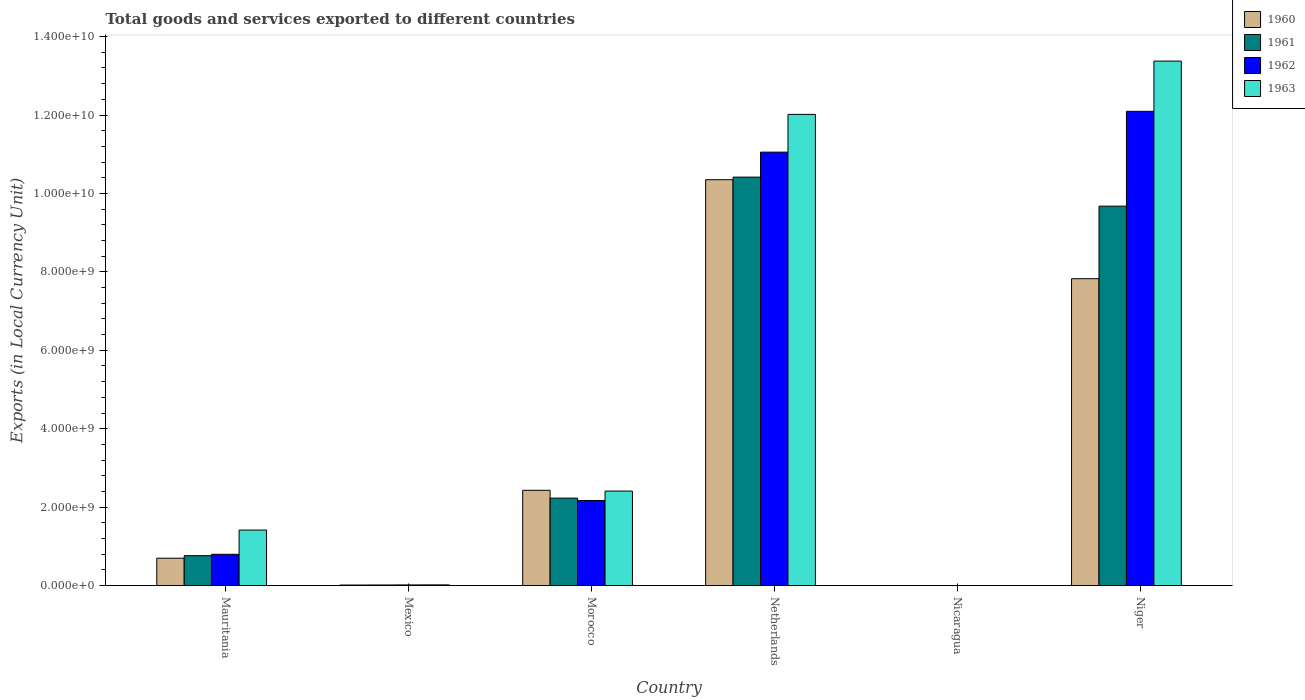How many different coloured bars are there?
Your answer should be very brief. 4. Are the number of bars on each tick of the X-axis equal?
Make the answer very short. Yes. How many bars are there on the 4th tick from the left?
Offer a terse response. 4. How many bars are there on the 6th tick from the right?
Keep it short and to the point. 4. What is the label of the 6th group of bars from the left?
Your answer should be very brief. Niger. In how many cases, is the number of bars for a given country not equal to the number of legend labels?
Make the answer very short. 0. What is the Amount of goods and services exports in 1962 in Netherlands?
Your answer should be very brief. 1.11e+1. Across all countries, what is the maximum Amount of goods and services exports in 1963?
Your answer should be compact. 1.34e+1. Across all countries, what is the minimum Amount of goods and services exports in 1963?
Provide a short and direct response. 0.18. In which country was the Amount of goods and services exports in 1963 maximum?
Offer a very short reply. Niger. In which country was the Amount of goods and services exports in 1961 minimum?
Make the answer very short. Nicaragua. What is the total Amount of goods and services exports in 1962 in the graph?
Your answer should be compact. 2.61e+1. What is the difference between the Amount of goods and services exports in 1962 in Morocco and that in Nicaragua?
Offer a terse response. 2.17e+09. What is the difference between the Amount of goods and services exports in 1962 in Morocco and the Amount of goods and services exports in 1960 in Niger?
Offer a terse response. -5.66e+09. What is the average Amount of goods and services exports in 1960 per country?
Your answer should be compact. 3.55e+09. What is the difference between the Amount of goods and services exports of/in 1962 and Amount of goods and services exports of/in 1963 in Netherlands?
Keep it short and to the point. -9.62e+08. In how many countries, is the Amount of goods and services exports in 1962 greater than 800000000 LCU?
Your response must be concise. 3. What is the ratio of the Amount of goods and services exports in 1963 in Nicaragua to that in Niger?
Ensure brevity in your answer.  1.3255828890398681e-11. Is the Amount of goods and services exports in 1960 in Mauritania less than that in Morocco?
Provide a succinct answer. Yes. Is the difference between the Amount of goods and services exports in 1962 in Mauritania and Niger greater than the difference between the Amount of goods and services exports in 1963 in Mauritania and Niger?
Your answer should be very brief. Yes. What is the difference between the highest and the second highest Amount of goods and services exports in 1961?
Make the answer very short. 8.19e+09. What is the difference between the highest and the lowest Amount of goods and services exports in 1960?
Provide a short and direct response. 1.04e+1. In how many countries, is the Amount of goods and services exports in 1962 greater than the average Amount of goods and services exports in 1962 taken over all countries?
Give a very brief answer. 2. Is the sum of the Amount of goods and services exports in 1960 in Morocco and Nicaragua greater than the maximum Amount of goods and services exports in 1961 across all countries?
Ensure brevity in your answer.  No. Is it the case that in every country, the sum of the Amount of goods and services exports in 1962 and Amount of goods and services exports in 1960 is greater than the sum of Amount of goods and services exports in 1963 and Amount of goods and services exports in 1961?
Make the answer very short. No. How many bars are there?
Provide a short and direct response. 24. Are all the bars in the graph horizontal?
Your answer should be compact. No. What is the difference between two consecutive major ticks on the Y-axis?
Provide a short and direct response. 2.00e+09. Does the graph contain grids?
Give a very brief answer. No. How many legend labels are there?
Offer a very short reply. 4. How are the legend labels stacked?
Make the answer very short. Vertical. What is the title of the graph?
Provide a succinct answer. Total goods and services exported to different countries. Does "2014" appear as one of the legend labels in the graph?
Provide a succinct answer. No. What is the label or title of the Y-axis?
Offer a very short reply. Exports (in Local Currency Unit). What is the Exports (in Local Currency Unit) of 1960 in Mauritania?
Your answer should be very brief. 6.98e+08. What is the Exports (in Local Currency Unit) in 1961 in Mauritania?
Your response must be concise. 7.63e+08. What is the Exports (in Local Currency Unit) of 1962 in Mauritania?
Provide a short and direct response. 7.98e+08. What is the Exports (in Local Currency Unit) of 1963 in Mauritania?
Offer a very short reply. 1.42e+09. What is the Exports (in Local Currency Unit) of 1960 in Mexico?
Offer a very short reply. 1.39e+07. What is the Exports (in Local Currency Unit) of 1961 in Mexico?
Ensure brevity in your answer.  1.49e+07. What is the Exports (in Local Currency Unit) of 1962 in Mexico?
Your response must be concise. 1.63e+07. What is the Exports (in Local Currency Unit) of 1963 in Mexico?
Keep it short and to the point. 1.76e+07. What is the Exports (in Local Currency Unit) in 1960 in Morocco?
Ensure brevity in your answer.  2.43e+09. What is the Exports (in Local Currency Unit) of 1961 in Morocco?
Offer a very short reply. 2.23e+09. What is the Exports (in Local Currency Unit) in 1962 in Morocco?
Your answer should be compact. 2.17e+09. What is the Exports (in Local Currency Unit) of 1963 in Morocco?
Give a very brief answer. 2.41e+09. What is the Exports (in Local Currency Unit) in 1960 in Netherlands?
Provide a succinct answer. 1.04e+1. What is the Exports (in Local Currency Unit) of 1961 in Netherlands?
Make the answer very short. 1.04e+1. What is the Exports (in Local Currency Unit) of 1962 in Netherlands?
Offer a very short reply. 1.11e+1. What is the Exports (in Local Currency Unit) of 1963 in Netherlands?
Ensure brevity in your answer.  1.20e+1. What is the Exports (in Local Currency Unit) of 1960 in Nicaragua?
Make the answer very short. 0.11. What is the Exports (in Local Currency Unit) in 1961 in Nicaragua?
Your answer should be compact. 0.12. What is the Exports (in Local Currency Unit) of 1962 in Nicaragua?
Make the answer very short. 0.15. What is the Exports (in Local Currency Unit) in 1963 in Nicaragua?
Make the answer very short. 0.18. What is the Exports (in Local Currency Unit) of 1960 in Niger?
Your answer should be very brief. 7.83e+09. What is the Exports (in Local Currency Unit) in 1961 in Niger?
Ensure brevity in your answer.  9.68e+09. What is the Exports (in Local Currency Unit) in 1962 in Niger?
Offer a terse response. 1.21e+1. What is the Exports (in Local Currency Unit) of 1963 in Niger?
Offer a very short reply. 1.34e+1. Across all countries, what is the maximum Exports (in Local Currency Unit) in 1960?
Your answer should be very brief. 1.04e+1. Across all countries, what is the maximum Exports (in Local Currency Unit) of 1961?
Give a very brief answer. 1.04e+1. Across all countries, what is the maximum Exports (in Local Currency Unit) of 1962?
Ensure brevity in your answer.  1.21e+1. Across all countries, what is the maximum Exports (in Local Currency Unit) of 1963?
Offer a very short reply. 1.34e+1. Across all countries, what is the minimum Exports (in Local Currency Unit) in 1960?
Provide a succinct answer. 0.11. Across all countries, what is the minimum Exports (in Local Currency Unit) in 1961?
Ensure brevity in your answer.  0.12. Across all countries, what is the minimum Exports (in Local Currency Unit) in 1962?
Ensure brevity in your answer.  0.15. Across all countries, what is the minimum Exports (in Local Currency Unit) of 1963?
Your answer should be very brief. 0.18. What is the total Exports (in Local Currency Unit) in 1960 in the graph?
Provide a succinct answer. 2.13e+1. What is the total Exports (in Local Currency Unit) in 1961 in the graph?
Your answer should be compact. 2.31e+1. What is the total Exports (in Local Currency Unit) in 1962 in the graph?
Offer a terse response. 2.61e+1. What is the total Exports (in Local Currency Unit) of 1963 in the graph?
Provide a succinct answer. 2.92e+1. What is the difference between the Exports (in Local Currency Unit) in 1960 in Mauritania and that in Mexico?
Keep it short and to the point. 6.84e+08. What is the difference between the Exports (in Local Currency Unit) in 1961 in Mauritania and that in Mexico?
Keep it short and to the point. 7.48e+08. What is the difference between the Exports (in Local Currency Unit) in 1962 in Mauritania and that in Mexico?
Give a very brief answer. 7.81e+08. What is the difference between the Exports (in Local Currency Unit) in 1963 in Mauritania and that in Mexico?
Give a very brief answer. 1.40e+09. What is the difference between the Exports (in Local Currency Unit) of 1960 in Mauritania and that in Morocco?
Offer a very short reply. -1.73e+09. What is the difference between the Exports (in Local Currency Unit) of 1961 in Mauritania and that in Morocco?
Make the answer very short. -1.47e+09. What is the difference between the Exports (in Local Currency Unit) of 1962 in Mauritania and that in Morocco?
Your response must be concise. -1.37e+09. What is the difference between the Exports (in Local Currency Unit) in 1963 in Mauritania and that in Morocco?
Make the answer very short. -9.94e+08. What is the difference between the Exports (in Local Currency Unit) in 1960 in Mauritania and that in Netherlands?
Keep it short and to the point. -9.65e+09. What is the difference between the Exports (in Local Currency Unit) of 1961 in Mauritania and that in Netherlands?
Your answer should be very brief. -9.65e+09. What is the difference between the Exports (in Local Currency Unit) of 1962 in Mauritania and that in Netherlands?
Provide a succinct answer. -1.03e+1. What is the difference between the Exports (in Local Currency Unit) of 1963 in Mauritania and that in Netherlands?
Provide a succinct answer. -1.06e+1. What is the difference between the Exports (in Local Currency Unit) of 1960 in Mauritania and that in Nicaragua?
Keep it short and to the point. 6.98e+08. What is the difference between the Exports (in Local Currency Unit) of 1961 in Mauritania and that in Nicaragua?
Ensure brevity in your answer.  7.63e+08. What is the difference between the Exports (in Local Currency Unit) of 1962 in Mauritania and that in Nicaragua?
Make the answer very short. 7.98e+08. What is the difference between the Exports (in Local Currency Unit) of 1963 in Mauritania and that in Nicaragua?
Make the answer very short. 1.42e+09. What is the difference between the Exports (in Local Currency Unit) in 1960 in Mauritania and that in Niger?
Offer a very short reply. -7.13e+09. What is the difference between the Exports (in Local Currency Unit) in 1961 in Mauritania and that in Niger?
Provide a short and direct response. -8.91e+09. What is the difference between the Exports (in Local Currency Unit) of 1962 in Mauritania and that in Niger?
Your response must be concise. -1.13e+1. What is the difference between the Exports (in Local Currency Unit) of 1963 in Mauritania and that in Niger?
Give a very brief answer. -1.20e+1. What is the difference between the Exports (in Local Currency Unit) of 1960 in Mexico and that in Morocco?
Provide a short and direct response. -2.42e+09. What is the difference between the Exports (in Local Currency Unit) in 1961 in Mexico and that in Morocco?
Your answer should be compact. -2.22e+09. What is the difference between the Exports (in Local Currency Unit) in 1962 in Mexico and that in Morocco?
Your answer should be compact. -2.15e+09. What is the difference between the Exports (in Local Currency Unit) in 1963 in Mexico and that in Morocco?
Keep it short and to the point. -2.39e+09. What is the difference between the Exports (in Local Currency Unit) in 1960 in Mexico and that in Netherlands?
Provide a succinct answer. -1.03e+1. What is the difference between the Exports (in Local Currency Unit) in 1961 in Mexico and that in Netherlands?
Offer a terse response. -1.04e+1. What is the difference between the Exports (in Local Currency Unit) in 1962 in Mexico and that in Netherlands?
Your answer should be compact. -1.10e+1. What is the difference between the Exports (in Local Currency Unit) of 1963 in Mexico and that in Netherlands?
Give a very brief answer. -1.20e+1. What is the difference between the Exports (in Local Currency Unit) of 1960 in Mexico and that in Nicaragua?
Give a very brief answer. 1.39e+07. What is the difference between the Exports (in Local Currency Unit) in 1961 in Mexico and that in Nicaragua?
Give a very brief answer. 1.49e+07. What is the difference between the Exports (in Local Currency Unit) of 1962 in Mexico and that in Nicaragua?
Your answer should be very brief. 1.63e+07. What is the difference between the Exports (in Local Currency Unit) in 1963 in Mexico and that in Nicaragua?
Make the answer very short. 1.76e+07. What is the difference between the Exports (in Local Currency Unit) in 1960 in Mexico and that in Niger?
Keep it short and to the point. -7.81e+09. What is the difference between the Exports (in Local Currency Unit) of 1961 in Mexico and that in Niger?
Keep it short and to the point. -9.66e+09. What is the difference between the Exports (in Local Currency Unit) in 1962 in Mexico and that in Niger?
Your answer should be very brief. -1.21e+1. What is the difference between the Exports (in Local Currency Unit) of 1963 in Mexico and that in Niger?
Provide a short and direct response. -1.34e+1. What is the difference between the Exports (in Local Currency Unit) in 1960 in Morocco and that in Netherlands?
Your answer should be very brief. -7.92e+09. What is the difference between the Exports (in Local Currency Unit) of 1961 in Morocco and that in Netherlands?
Make the answer very short. -8.19e+09. What is the difference between the Exports (in Local Currency Unit) of 1962 in Morocco and that in Netherlands?
Your response must be concise. -8.88e+09. What is the difference between the Exports (in Local Currency Unit) of 1963 in Morocco and that in Netherlands?
Ensure brevity in your answer.  -9.61e+09. What is the difference between the Exports (in Local Currency Unit) in 1960 in Morocco and that in Nicaragua?
Ensure brevity in your answer.  2.43e+09. What is the difference between the Exports (in Local Currency Unit) of 1961 in Morocco and that in Nicaragua?
Ensure brevity in your answer.  2.23e+09. What is the difference between the Exports (in Local Currency Unit) of 1962 in Morocco and that in Nicaragua?
Your answer should be very brief. 2.17e+09. What is the difference between the Exports (in Local Currency Unit) of 1963 in Morocco and that in Nicaragua?
Your answer should be very brief. 2.41e+09. What is the difference between the Exports (in Local Currency Unit) in 1960 in Morocco and that in Niger?
Keep it short and to the point. -5.40e+09. What is the difference between the Exports (in Local Currency Unit) of 1961 in Morocco and that in Niger?
Your response must be concise. -7.45e+09. What is the difference between the Exports (in Local Currency Unit) in 1962 in Morocco and that in Niger?
Make the answer very short. -9.92e+09. What is the difference between the Exports (in Local Currency Unit) of 1963 in Morocco and that in Niger?
Your answer should be very brief. -1.10e+1. What is the difference between the Exports (in Local Currency Unit) in 1960 in Netherlands and that in Nicaragua?
Your answer should be compact. 1.04e+1. What is the difference between the Exports (in Local Currency Unit) of 1961 in Netherlands and that in Nicaragua?
Offer a terse response. 1.04e+1. What is the difference between the Exports (in Local Currency Unit) in 1962 in Netherlands and that in Nicaragua?
Offer a terse response. 1.11e+1. What is the difference between the Exports (in Local Currency Unit) of 1963 in Netherlands and that in Nicaragua?
Your response must be concise. 1.20e+1. What is the difference between the Exports (in Local Currency Unit) in 1960 in Netherlands and that in Niger?
Your answer should be very brief. 2.52e+09. What is the difference between the Exports (in Local Currency Unit) of 1961 in Netherlands and that in Niger?
Your response must be concise. 7.41e+08. What is the difference between the Exports (in Local Currency Unit) of 1962 in Netherlands and that in Niger?
Your answer should be compact. -1.04e+09. What is the difference between the Exports (in Local Currency Unit) of 1963 in Netherlands and that in Niger?
Make the answer very short. -1.36e+09. What is the difference between the Exports (in Local Currency Unit) of 1960 in Nicaragua and that in Niger?
Ensure brevity in your answer.  -7.83e+09. What is the difference between the Exports (in Local Currency Unit) of 1961 in Nicaragua and that in Niger?
Offer a terse response. -9.68e+09. What is the difference between the Exports (in Local Currency Unit) of 1962 in Nicaragua and that in Niger?
Make the answer very short. -1.21e+1. What is the difference between the Exports (in Local Currency Unit) of 1963 in Nicaragua and that in Niger?
Provide a short and direct response. -1.34e+1. What is the difference between the Exports (in Local Currency Unit) in 1960 in Mauritania and the Exports (in Local Currency Unit) in 1961 in Mexico?
Offer a very short reply. 6.83e+08. What is the difference between the Exports (in Local Currency Unit) in 1960 in Mauritania and the Exports (in Local Currency Unit) in 1962 in Mexico?
Provide a short and direct response. 6.82e+08. What is the difference between the Exports (in Local Currency Unit) of 1960 in Mauritania and the Exports (in Local Currency Unit) of 1963 in Mexico?
Keep it short and to the point. 6.80e+08. What is the difference between the Exports (in Local Currency Unit) of 1961 in Mauritania and the Exports (in Local Currency Unit) of 1962 in Mexico?
Offer a terse response. 7.46e+08. What is the difference between the Exports (in Local Currency Unit) of 1961 in Mauritania and the Exports (in Local Currency Unit) of 1963 in Mexico?
Provide a succinct answer. 7.45e+08. What is the difference between the Exports (in Local Currency Unit) in 1962 in Mauritania and the Exports (in Local Currency Unit) in 1963 in Mexico?
Your answer should be very brief. 7.80e+08. What is the difference between the Exports (in Local Currency Unit) of 1960 in Mauritania and the Exports (in Local Currency Unit) of 1961 in Morocco?
Keep it short and to the point. -1.53e+09. What is the difference between the Exports (in Local Currency Unit) in 1960 in Mauritania and the Exports (in Local Currency Unit) in 1962 in Morocco?
Offer a very short reply. -1.47e+09. What is the difference between the Exports (in Local Currency Unit) in 1960 in Mauritania and the Exports (in Local Currency Unit) in 1963 in Morocco?
Offer a very short reply. -1.71e+09. What is the difference between the Exports (in Local Currency Unit) in 1961 in Mauritania and the Exports (in Local Currency Unit) in 1962 in Morocco?
Keep it short and to the point. -1.41e+09. What is the difference between the Exports (in Local Currency Unit) of 1961 in Mauritania and the Exports (in Local Currency Unit) of 1963 in Morocco?
Offer a terse response. -1.65e+09. What is the difference between the Exports (in Local Currency Unit) in 1962 in Mauritania and the Exports (in Local Currency Unit) in 1963 in Morocco?
Give a very brief answer. -1.61e+09. What is the difference between the Exports (in Local Currency Unit) of 1960 in Mauritania and the Exports (in Local Currency Unit) of 1961 in Netherlands?
Keep it short and to the point. -9.72e+09. What is the difference between the Exports (in Local Currency Unit) in 1960 in Mauritania and the Exports (in Local Currency Unit) in 1962 in Netherlands?
Offer a very short reply. -1.04e+1. What is the difference between the Exports (in Local Currency Unit) in 1960 in Mauritania and the Exports (in Local Currency Unit) in 1963 in Netherlands?
Offer a very short reply. -1.13e+1. What is the difference between the Exports (in Local Currency Unit) in 1961 in Mauritania and the Exports (in Local Currency Unit) in 1962 in Netherlands?
Give a very brief answer. -1.03e+1. What is the difference between the Exports (in Local Currency Unit) in 1961 in Mauritania and the Exports (in Local Currency Unit) in 1963 in Netherlands?
Your response must be concise. -1.13e+1. What is the difference between the Exports (in Local Currency Unit) of 1962 in Mauritania and the Exports (in Local Currency Unit) of 1963 in Netherlands?
Your answer should be compact. -1.12e+1. What is the difference between the Exports (in Local Currency Unit) in 1960 in Mauritania and the Exports (in Local Currency Unit) in 1961 in Nicaragua?
Provide a succinct answer. 6.98e+08. What is the difference between the Exports (in Local Currency Unit) of 1960 in Mauritania and the Exports (in Local Currency Unit) of 1962 in Nicaragua?
Ensure brevity in your answer.  6.98e+08. What is the difference between the Exports (in Local Currency Unit) in 1960 in Mauritania and the Exports (in Local Currency Unit) in 1963 in Nicaragua?
Keep it short and to the point. 6.98e+08. What is the difference between the Exports (in Local Currency Unit) of 1961 in Mauritania and the Exports (in Local Currency Unit) of 1962 in Nicaragua?
Make the answer very short. 7.63e+08. What is the difference between the Exports (in Local Currency Unit) in 1961 in Mauritania and the Exports (in Local Currency Unit) in 1963 in Nicaragua?
Make the answer very short. 7.63e+08. What is the difference between the Exports (in Local Currency Unit) in 1962 in Mauritania and the Exports (in Local Currency Unit) in 1963 in Nicaragua?
Make the answer very short. 7.98e+08. What is the difference between the Exports (in Local Currency Unit) of 1960 in Mauritania and the Exports (in Local Currency Unit) of 1961 in Niger?
Your response must be concise. -8.98e+09. What is the difference between the Exports (in Local Currency Unit) of 1960 in Mauritania and the Exports (in Local Currency Unit) of 1962 in Niger?
Provide a short and direct response. -1.14e+1. What is the difference between the Exports (in Local Currency Unit) in 1960 in Mauritania and the Exports (in Local Currency Unit) in 1963 in Niger?
Offer a very short reply. -1.27e+1. What is the difference between the Exports (in Local Currency Unit) of 1961 in Mauritania and the Exports (in Local Currency Unit) of 1962 in Niger?
Your answer should be compact. -1.13e+1. What is the difference between the Exports (in Local Currency Unit) of 1961 in Mauritania and the Exports (in Local Currency Unit) of 1963 in Niger?
Ensure brevity in your answer.  -1.26e+1. What is the difference between the Exports (in Local Currency Unit) of 1962 in Mauritania and the Exports (in Local Currency Unit) of 1963 in Niger?
Offer a terse response. -1.26e+1. What is the difference between the Exports (in Local Currency Unit) of 1960 in Mexico and the Exports (in Local Currency Unit) of 1961 in Morocco?
Your answer should be compact. -2.22e+09. What is the difference between the Exports (in Local Currency Unit) in 1960 in Mexico and the Exports (in Local Currency Unit) in 1962 in Morocco?
Your answer should be very brief. -2.16e+09. What is the difference between the Exports (in Local Currency Unit) in 1960 in Mexico and the Exports (in Local Currency Unit) in 1963 in Morocco?
Offer a very short reply. -2.40e+09. What is the difference between the Exports (in Local Currency Unit) of 1961 in Mexico and the Exports (in Local Currency Unit) of 1962 in Morocco?
Provide a succinct answer. -2.16e+09. What is the difference between the Exports (in Local Currency Unit) in 1961 in Mexico and the Exports (in Local Currency Unit) in 1963 in Morocco?
Your answer should be very brief. -2.40e+09. What is the difference between the Exports (in Local Currency Unit) of 1962 in Mexico and the Exports (in Local Currency Unit) of 1963 in Morocco?
Make the answer very short. -2.39e+09. What is the difference between the Exports (in Local Currency Unit) in 1960 in Mexico and the Exports (in Local Currency Unit) in 1961 in Netherlands?
Make the answer very short. -1.04e+1. What is the difference between the Exports (in Local Currency Unit) of 1960 in Mexico and the Exports (in Local Currency Unit) of 1962 in Netherlands?
Your answer should be compact. -1.10e+1. What is the difference between the Exports (in Local Currency Unit) in 1960 in Mexico and the Exports (in Local Currency Unit) in 1963 in Netherlands?
Provide a short and direct response. -1.20e+1. What is the difference between the Exports (in Local Currency Unit) of 1961 in Mexico and the Exports (in Local Currency Unit) of 1962 in Netherlands?
Your answer should be compact. -1.10e+1. What is the difference between the Exports (in Local Currency Unit) in 1961 in Mexico and the Exports (in Local Currency Unit) in 1963 in Netherlands?
Ensure brevity in your answer.  -1.20e+1. What is the difference between the Exports (in Local Currency Unit) of 1962 in Mexico and the Exports (in Local Currency Unit) of 1963 in Netherlands?
Keep it short and to the point. -1.20e+1. What is the difference between the Exports (in Local Currency Unit) of 1960 in Mexico and the Exports (in Local Currency Unit) of 1961 in Nicaragua?
Ensure brevity in your answer.  1.39e+07. What is the difference between the Exports (in Local Currency Unit) of 1960 in Mexico and the Exports (in Local Currency Unit) of 1962 in Nicaragua?
Make the answer very short. 1.39e+07. What is the difference between the Exports (in Local Currency Unit) in 1960 in Mexico and the Exports (in Local Currency Unit) in 1963 in Nicaragua?
Offer a very short reply. 1.39e+07. What is the difference between the Exports (in Local Currency Unit) of 1961 in Mexico and the Exports (in Local Currency Unit) of 1962 in Nicaragua?
Offer a terse response. 1.49e+07. What is the difference between the Exports (in Local Currency Unit) in 1961 in Mexico and the Exports (in Local Currency Unit) in 1963 in Nicaragua?
Provide a succinct answer. 1.49e+07. What is the difference between the Exports (in Local Currency Unit) in 1962 in Mexico and the Exports (in Local Currency Unit) in 1963 in Nicaragua?
Keep it short and to the point. 1.63e+07. What is the difference between the Exports (in Local Currency Unit) of 1960 in Mexico and the Exports (in Local Currency Unit) of 1961 in Niger?
Your answer should be compact. -9.66e+09. What is the difference between the Exports (in Local Currency Unit) in 1960 in Mexico and the Exports (in Local Currency Unit) in 1962 in Niger?
Your response must be concise. -1.21e+1. What is the difference between the Exports (in Local Currency Unit) in 1960 in Mexico and the Exports (in Local Currency Unit) in 1963 in Niger?
Keep it short and to the point. -1.34e+1. What is the difference between the Exports (in Local Currency Unit) in 1961 in Mexico and the Exports (in Local Currency Unit) in 1962 in Niger?
Offer a very short reply. -1.21e+1. What is the difference between the Exports (in Local Currency Unit) of 1961 in Mexico and the Exports (in Local Currency Unit) of 1963 in Niger?
Provide a short and direct response. -1.34e+1. What is the difference between the Exports (in Local Currency Unit) of 1962 in Mexico and the Exports (in Local Currency Unit) of 1963 in Niger?
Offer a very short reply. -1.34e+1. What is the difference between the Exports (in Local Currency Unit) of 1960 in Morocco and the Exports (in Local Currency Unit) of 1961 in Netherlands?
Give a very brief answer. -7.99e+09. What is the difference between the Exports (in Local Currency Unit) in 1960 in Morocco and the Exports (in Local Currency Unit) in 1962 in Netherlands?
Ensure brevity in your answer.  -8.62e+09. What is the difference between the Exports (in Local Currency Unit) of 1960 in Morocco and the Exports (in Local Currency Unit) of 1963 in Netherlands?
Make the answer very short. -9.59e+09. What is the difference between the Exports (in Local Currency Unit) of 1961 in Morocco and the Exports (in Local Currency Unit) of 1962 in Netherlands?
Keep it short and to the point. -8.82e+09. What is the difference between the Exports (in Local Currency Unit) of 1961 in Morocco and the Exports (in Local Currency Unit) of 1963 in Netherlands?
Keep it short and to the point. -9.79e+09. What is the difference between the Exports (in Local Currency Unit) in 1962 in Morocco and the Exports (in Local Currency Unit) in 1963 in Netherlands?
Make the answer very short. -9.85e+09. What is the difference between the Exports (in Local Currency Unit) in 1960 in Morocco and the Exports (in Local Currency Unit) in 1961 in Nicaragua?
Give a very brief answer. 2.43e+09. What is the difference between the Exports (in Local Currency Unit) in 1960 in Morocco and the Exports (in Local Currency Unit) in 1962 in Nicaragua?
Give a very brief answer. 2.43e+09. What is the difference between the Exports (in Local Currency Unit) of 1960 in Morocco and the Exports (in Local Currency Unit) of 1963 in Nicaragua?
Make the answer very short. 2.43e+09. What is the difference between the Exports (in Local Currency Unit) of 1961 in Morocco and the Exports (in Local Currency Unit) of 1962 in Nicaragua?
Offer a very short reply. 2.23e+09. What is the difference between the Exports (in Local Currency Unit) of 1961 in Morocco and the Exports (in Local Currency Unit) of 1963 in Nicaragua?
Offer a very short reply. 2.23e+09. What is the difference between the Exports (in Local Currency Unit) in 1962 in Morocco and the Exports (in Local Currency Unit) in 1963 in Nicaragua?
Provide a short and direct response. 2.17e+09. What is the difference between the Exports (in Local Currency Unit) of 1960 in Morocco and the Exports (in Local Currency Unit) of 1961 in Niger?
Your answer should be compact. -7.25e+09. What is the difference between the Exports (in Local Currency Unit) in 1960 in Morocco and the Exports (in Local Currency Unit) in 1962 in Niger?
Ensure brevity in your answer.  -9.66e+09. What is the difference between the Exports (in Local Currency Unit) in 1960 in Morocco and the Exports (in Local Currency Unit) in 1963 in Niger?
Your response must be concise. -1.09e+1. What is the difference between the Exports (in Local Currency Unit) of 1961 in Morocco and the Exports (in Local Currency Unit) of 1962 in Niger?
Make the answer very short. -9.86e+09. What is the difference between the Exports (in Local Currency Unit) in 1961 in Morocco and the Exports (in Local Currency Unit) in 1963 in Niger?
Make the answer very short. -1.11e+1. What is the difference between the Exports (in Local Currency Unit) of 1962 in Morocco and the Exports (in Local Currency Unit) of 1963 in Niger?
Make the answer very short. -1.12e+1. What is the difference between the Exports (in Local Currency Unit) of 1960 in Netherlands and the Exports (in Local Currency Unit) of 1961 in Nicaragua?
Give a very brief answer. 1.04e+1. What is the difference between the Exports (in Local Currency Unit) of 1960 in Netherlands and the Exports (in Local Currency Unit) of 1962 in Nicaragua?
Your answer should be compact. 1.04e+1. What is the difference between the Exports (in Local Currency Unit) in 1960 in Netherlands and the Exports (in Local Currency Unit) in 1963 in Nicaragua?
Offer a very short reply. 1.04e+1. What is the difference between the Exports (in Local Currency Unit) of 1961 in Netherlands and the Exports (in Local Currency Unit) of 1962 in Nicaragua?
Make the answer very short. 1.04e+1. What is the difference between the Exports (in Local Currency Unit) of 1961 in Netherlands and the Exports (in Local Currency Unit) of 1963 in Nicaragua?
Your answer should be compact. 1.04e+1. What is the difference between the Exports (in Local Currency Unit) of 1962 in Netherlands and the Exports (in Local Currency Unit) of 1963 in Nicaragua?
Your response must be concise. 1.11e+1. What is the difference between the Exports (in Local Currency Unit) in 1960 in Netherlands and the Exports (in Local Currency Unit) in 1961 in Niger?
Keep it short and to the point. 6.75e+08. What is the difference between the Exports (in Local Currency Unit) in 1960 in Netherlands and the Exports (in Local Currency Unit) in 1962 in Niger?
Ensure brevity in your answer.  -1.74e+09. What is the difference between the Exports (in Local Currency Unit) in 1960 in Netherlands and the Exports (in Local Currency Unit) in 1963 in Niger?
Offer a terse response. -3.02e+09. What is the difference between the Exports (in Local Currency Unit) in 1961 in Netherlands and the Exports (in Local Currency Unit) in 1962 in Niger?
Provide a succinct answer. -1.68e+09. What is the difference between the Exports (in Local Currency Unit) in 1961 in Netherlands and the Exports (in Local Currency Unit) in 1963 in Niger?
Your answer should be very brief. -2.96e+09. What is the difference between the Exports (in Local Currency Unit) of 1962 in Netherlands and the Exports (in Local Currency Unit) of 1963 in Niger?
Give a very brief answer. -2.32e+09. What is the difference between the Exports (in Local Currency Unit) of 1960 in Nicaragua and the Exports (in Local Currency Unit) of 1961 in Niger?
Offer a terse response. -9.68e+09. What is the difference between the Exports (in Local Currency Unit) in 1960 in Nicaragua and the Exports (in Local Currency Unit) in 1962 in Niger?
Offer a very short reply. -1.21e+1. What is the difference between the Exports (in Local Currency Unit) in 1960 in Nicaragua and the Exports (in Local Currency Unit) in 1963 in Niger?
Offer a terse response. -1.34e+1. What is the difference between the Exports (in Local Currency Unit) of 1961 in Nicaragua and the Exports (in Local Currency Unit) of 1962 in Niger?
Your response must be concise. -1.21e+1. What is the difference between the Exports (in Local Currency Unit) of 1961 in Nicaragua and the Exports (in Local Currency Unit) of 1963 in Niger?
Your response must be concise. -1.34e+1. What is the difference between the Exports (in Local Currency Unit) in 1962 in Nicaragua and the Exports (in Local Currency Unit) in 1963 in Niger?
Provide a succinct answer. -1.34e+1. What is the average Exports (in Local Currency Unit) of 1960 per country?
Provide a short and direct response. 3.55e+09. What is the average Exports (in Local Currency Unit) of 1961 per country?
Provide a succinct answer. 3.85e+09. What is the average Exports (in Local Currency Unit) in 1962 per country?
Provide a short and direct response. 4.36e+09. What is the average Exports (in Local Currency Unit) of 1963 per country?
Your answer should be compact. 4.87e+09. What is the difference between the Exports (in Local Currency Unit) in 1960 and Exports (in Local Currency Unit) in 1961 in Mauritania?
Offer a terse response. -6.48e+07. What is the difference between the Exports (in Local Currency Unit) of 1960 and Exports (in Local Currency Unit) of 1962 in Mauritania?
Make the answer very short. -9.97e+07. What is the difference between the Exports (in Local Currency Unit) of 1960 and Exports (in Local Currency Unit) of 1963 in Mauritania?
Your answer should be compact. -7.18e+08. What is the difference between the Exports (in Local Currency Unit) of 1961 and Exports (in Local Currency Unit) of 1962 in Mauritania?
Make the answer very short. -3.49e+07. What is the difference between the Exports (in Local Currency Unit) of 1961 and Exports (in Local Currency Unit) of 1963 in Mauritania?
Provide a succinct answer. -6.53e+08. What is the difference between the Exports (in Local Currency Unit) in 1962 and Exports (in Local Currency Unit) in 1963 in Mauritania?
Keep it short and to the point. -6.18e+08. What is the difference between the Exports (in Local Currency Unit) in 1960 and Exports (in Local Currency Unit) in 1961 in Mexico?
Offer a very short reply. -1.03e+06. What is the difference between the Exports (in Local Currency Unit) in 1960 and Exports (in Local Currency Unit) in 1962 in Mexico?
Give a very brief answer. -2.42e+06. What is the difference between the Exports (in Local Currency Unit) of 1960 and Exports (in Local Currency Unit) of 1963 in Mexico?
Your response must be concise. -3.77e+06. What is the difference between the Exports (in Local Currency Unit) of 1961 and Exports (in Local Currency Unit) of 1962 in Mexico?
Offer a very short reply. -1.39e+06. What is the difference between the Exports (in Local Currency Unit) in 1961 and Exports (in Local Currency Unit) in 1963 in Mexico?
Your answer should be very brief. -2.75e+06. What is the difference between the Exports (in Local Currency Unit) in 1962 and Exports (in Local Currency Unit) in 1963 in Mexico?
Your answer should be very brief. -1.36e+06. What is the difference between the Exports (in Local Currency Unit) of 1960 and Exports (in Local Currency Unit) of 1961 in Morocco?
Keep it short and to the point. 2.00e+08. What is the difference between the Exports (in Local Currency Unit) in 1960 and Exports (in Local Currency Unit) in 1962 in Morocco?
Your answer should be compact. 2.60e+08. What is the difference between the Exports (in Local Currency Unit) in 1960 and Exports (in Local Currency Unit) in 1963 in Morocco?
Give a very brief answer. 2.00e+07. What is the difference between the Exports (in Local Currency Unit) of 1961 and Exports (in Local Currency Unit) of 1962 in Morocco?
Provide a succinct answer. 6.00e+07. What is the difference between the Exports (in Local Currency Unit) of 1961 and Exports (in Local Currency Unit) of 1963 in Morocco?
Keep it short and to the point. -1.80e+08. What is the difference between the Exports (in Local Currency Unit) of 1962 and Exports (in Local Currency Unit) of 1963 in Morocco?
Your answer should be compact. -2.40e+08. What is the difference between the Exports (in Local Currency Unit) in 1960 and Exports (in Local Currency Unit) in 1961 in Netherlands?
Your answer should be very brief. -6.60e+07. What is the difference between the Exports (in Local Currency Unit) of 1960 and Exports (in Local Currency Unit) of 1962 in Netherlands?
Offer a very short reply. -7.03e+08. What is the difference between the Exports (in Local Currency Unit) in 1960 and Exports (in Local Currency Unit) in 1963 in Netherlands?
Offer a terse response. -1.67e+09. What is the difference between the Exports (in Local Currency Unit) of 1961 and Exports (in Local Currency Unit) of 1962 in Netherlands?
Your response must be concise. -6.37e+08. What is the difference between the Exports (in Local Currency Unit) in 1961 and Exports (in Local Currency Unit) in 1963 in Netherlands?
Your answer should be compact. -1.60e+09. What is the difference between the Exports (in Local Currency Unit) of 1962 and Exports (in Local Currency Unit) of 1963 in Netherlands?
Offer a very short reply. -9.62e+08. What is the difference between the Exports (in Local Currency Unit) in 1960 and Exports (in Local Currency Unit) in 1961 in Nicaragua?
Your answer should be very brief. -0.01. What is the difference between the Exports (in Local Currency Unit) of 1960 and Exports (in Local Currency Unit) of 1962 in Nicaragua?
Give a very brief answer. -0.04. What is the difference between the Exports (in Local Currency Unit) in 1960 and Exports (in Local Currency Unit) in 1963 in Nicaragua?
Give a very brief answer. -0.07. What is the difference between the Exports (in Local Currency Unit) of 1961 and Exports (in Local Currency Unit) of 1962 in Nicaragua?
Your answer should be compact. -0.03. What is the difference between the Exports (in Local Currency Unit) of 1961 and Exports (in Local Currency Unit) of 1963 in Nicaragua?
Your response must be concise. -0.06. What is the difference between the Exports (in Local Currency Unit) of 1962 and Exports (in Local Currency Unit) of 1963 in Nicaragua?
Keep it short and to the point. -0.03. What is the difference between the Exports (in Local Currency Unit) in 1960 and Exports (in Local Currency Unit) in 1961 in Niger?
Ensure brevity in your answer.  -1.85e+09. What is the difference between the Exports (in Local Currency Unit) of 1960 and Exports (in Local Currency Unit) of 1962 in Niger?
Offer a terse response. -4.27e+09. What is the difference between the Exports (in Local Currency Unit) in 1960 and Exports (in Local Currency Unit) in 1963 in Niger?
Keep it short and to the point. -5.55e+09. What is the difference between the Exports (in Local Currency Unit) of 1961 and Exports (in Local Currency Unit) of 1962 in Niger?
Provide a short and direct response. -2.42e+09. What is the difference between the Exports (in Local Currency Unit) in 1961 and Exports (in Local Currency Unit) in 1963 in Niger?
Offer a terse response. -3.70e+09. What is the difference between the Exports (in Local Currency Unit) of 1962 and Exports (in Local Currency Unit) of 1963 in Niger?
Offer a very short reply. -1.28e+09. What is the ratio of the Exports (in Local Currency Unit) in 1960 in Mauritania to that in Mexico?
Ensure brevity in your answer.  50.34. What is the ratio of the Exports (in Local Currency Unit) of 1961 in Mauritania to that in Mexico?
Offer a terse response. 51.22. What is the ratio of the Exports (in Local Currency Unit) of 1962 in Mauritania to that in Mexico?
Ensure brevity in your answer.  48.99. What is the ratio of the Exports (in Local Currency Unit) of 1963 in Mauritania to that in Mexico?
Give a very brief answer. 80.26. What is the ratio of the Exports (in Local Currency Unit) in 1960 in Mauritania to that in Morocco?
Keep it short and to the point. 0.29. What is the ratio of the Exports (in Local Currency Unit) of 1961 in Mauritania to that in Morocco?
Your response must be concise. 0.34. What is the ratio of the Exports (in Local Currency Unit) of 1962 in Mauritania to that in Morocco?
Ensure brevity in your answer.  0.37. What is the ratio of the Exports (in Local Currency Unit) of 1963 in Mauritania to that in Morocco?
Provide a short and direct response. 0.59. What is the ratio of the Exports (in Local Currency Unit) in 1960 in Mauritania to that in Netherlands?
Your answer should be very brief. 0.07. What is the ratio of the Exports (in Local Currency Unit) in 1961 in Mauritania to that in Netherlands?
Make the answer very short. 0.07. What is the ratio of the Exports (in Local Currency Unit) in 1962 in Mauritania to that in Netherlands?
Make the answer very short. 0.07. What is the ratio of the Exports (in Local Currency Unit) in 1963 in Mauritania to that in Netherlands?
Give a very brief answer. 0.12. What is the ratio of the Exports (in Local Currency Unit) in 1960 in Mauritania to that in Nicaragua?
Provide a succinct answer. 6.28e+09. What is the ratio of the Exports (in Local Currency Unit) in 1961 in Mauritania to that in Nicaragua?
Your response must be concise. 6.45e+09. What is the ratio of the Exports (in Local Currency Unit) of 1962 in Mauritania to that in Nicaragua?
Give a very brief answer. 5.42e+09. What is the ratio of the Exports (in Local Currency Unit) of 1963 in Mauritania to that in Nicaragua?
Give a very brief answer. 7.98e+09. What is the ratio of the Exports (in Local Currency Unit) of 1960 in Mauritania to that in Niger?
Provide a succinct answer. 0.09. What is the ratio of the Exports (in Local Currency Unit) of 1961 in Mauritania to that in Niger?
Offer a terse response. 0.08. What is the ratio of the Exports (in Local Currency Unit) in 1962 in Mauritania to that in Niger?
Offer a very short reply. 0.07. What is the ratio of the Exports (in Local Currency Unit) of 1963 in Mauritania to that in Niger?
Offer a terse response. 0.11. What is the ratio of the Exports (in Local Currency Unit) in 1960 in Mexico to that in Morocco?
Your answer should be very brief. 0.01. What is the ratio of the Exports (in Local Currency Unit) in 1961 in Mexico to that in Morocco?
Provide a short and direct response. 0.01. What is the ratio of the Exports (in Local Currency Unit) in 1962 in Mexico to that in Morocco?
Your response must be concise. 0.01. What is the ratio of the Exports (in Local Currency Unit) of 1963 in Mexico to that in Morocco?
Provide a succinct answer. 0.01. What is the ratio of the Exports (in Local Currency Unit) in 1960 in Mexico to that in Netherlands?
Provide a short and direct response. 0. What is the ratio of the Exports (in Local Currency Unit) in 1961 in Mexico to that in Netherlands?
Keep it short and to the point. 0. What is the ratio of the Exports (in Local Currency Unit) in 1962 in Mexico to that in Netherlands?
Offer a very short reply. 0. What is the ratio of the Exports (in Local Currency Unit) in 1963 in Mexico to that in Netherlands?
Offer a very short reply. 0. What is the ratio of the Exports (in Local Currency Unit) in 1960 in Mexico to that in Nicaragua?
Offer a terse response. 1.25e+08. What is the ratio of the Exports (in Local Currency Unit) in 1961 in Mexico to that in Nicaragua?
Offer a very short reply. 1.26e+08. What is the ratio of the Exports (in Local Currency Unit) in 1962 in Mexico to that in Nicaragua?
Provide a short and direct response. 1.11e+08. What is the ratio of the Exports (in Local Currency Unit) of 1963 in Mexico to that in Nicaragua?
Provide a succinct answer. 9.95e+07. What is the ratio of the Exports (in Local Currency Unit) of 1960 in Mexico to that in Niger?
Give a very brief answer. 0. What is the ratio of the Exports (in Local Currency Unit) in 1961 in Mexico to that in Niger?
Provide a succinct answer. 0. What is the ratio of the Exports (in Local Currency Unit) of 1962 in Mexico to that in Niger?
Your response must be concise. 0. What is the ratio of the Exports (in Local Currency Unit) in 1963 in Mexico to that in Niger?
Ensure brevity in your answer.  0. What is the ratio of the Exports (in Local Currency Unit) in 1960 in Morocco to that in Netherlands?
Provide a short and direct response. 0.23. What is the ratio of the Exports (in Local Currency Unit) of 1961 in Morocco to that in Netherlands?
Make the answer very short. 0.21. What is the ratio of the Exports (in Local Currency Unit) in 1962 in Morocco to that in Netherlands?
Offer a very short reply. 0.2. What is the ratio of the Exports (in Local Currency Unit) of 1963 in Morocco to that in Netherlands?
Offer a terse response. 0.2. What is the ratio of the Exports (in Local Currency Unit) of 1960 in Morocco to that in Nicaragua?
Offer a very short reply. 2.19e+1. What is the ratio of the Exports (in Local Currency Unit) of 1961 in Morocco to that in Nicaragua?
Ensure brevity in your answer.  1.89e+1. What is the ratio of the Exports (in Local Currency Unit) in 1962 in Morocco to that in Nicaragua?
Your response must be concise. 1.47e+1. What is the ratio of the Exports (in Local Currency Unit) of 1963 in Morocco to that in Nicaragua?
Ensure brevity in your answer.  1.36e+1. What is the ratio of the Exports (in Local Currency Unit) of 1960 in Morocco to that in Niger?
Your response must be concise. 0.31. What is the ratio of the Exports (in Local Currency Unit) of 1961 in Morocco to that in Niger?
Offer a terse response. 0.23. What is the ratio of the Exports (in Local Currency Unit) of 1962 in Morocco to that in Niger?
Offer a terse response. 0.18. What is the ratio of the Exports (in Local Currency Unit) of 1963 in Morocco to that in Niger?
Give a very brief answer. 0.18. What is the ratio of the Exports (in Local Currency Unit) in 1960 in Netherlands to that in Nicaragua?
Keep it short and to the point. 9.31e+1. What is the ratio of the Exports (in Local Currency Unit) in 1961 in Netherlands to that in Nicaragua?
Your answer should be very brief. 8.81e+1. What is the ratio of the Exports (in Local Currency Unit) in 1962 in Netherlands to that in Nicaragua?
Your response must be concise. 7.51e+1. What is the ratio of the Exports (in Local Currency Unit) in 1963 in Netherlands to that in Nicaragua?
Your answer should be very brief. 6.78e+1. What is the ratio of the Exports (in Local Currency Unit) in 1960 in Netherlands to that in Niger?
Provide a short and direct response. 1.32. What is the ratio of the Exports (in Local Currency Unit) of 1961 in Netherlands to that in Niger?
Keep it short and to the point. 1.08. What is the ratio of the Exports (in Local Currency Unit) of 1962 in Netherlands to that in Niger?
Provide a succinct answer. 0.91. What is the ratio of the Exports (in Local Currency Unit) of 1963 in Netherlands to that in Niger?
Provide a short and direct response. 0.9. What is the ratio of the Exports (in Local Currency Unit) of 1961 in Nicaragua to that in Niger?
Provide a succinct answer. 0. What is the ratio of the Exports (in Local Currency Unit) in 1962 in Nicaragua to that in Niger?
Provide a short and direct response. 0. What is the difference between the highest and the second highest Exports (in Local Currency Unit) of 1960?
Provide a short and direct response. 2.52e+09. What is the difference between the highest and the second highest Exports (in Local Currency Unit) of 1961?
Ensure brevity in your answer.  7.41e+08. What is the difference between the highest and the second highest Exports (in Local Currency Unit) of 1962?
Provide a succinct answer. 1.04e+09. What is the difference between the highest and the second highest Exports (in Local Currency Unit) in 1963?
Offer a terse response. 1.36e+09. What is the difference between the highest and the lowest Exports (in Local Currency Unit) in 1960?
Your answer should be very brief. 1.04e+1. What is the difference between the highest and the lowest Exports (in Local Currency Unit) in 1961?
Provide a short and direct response. 1.04e+1. What is the difference between the highest and the lowest Exports (in Local Currency Unit) in 1962?
Offer a terse response. 1.21e+1. What is the difference between the highest and the lowest Exports (in Local Currency Unit) of 1963?
Offer a terse response. 1.34e+1. 